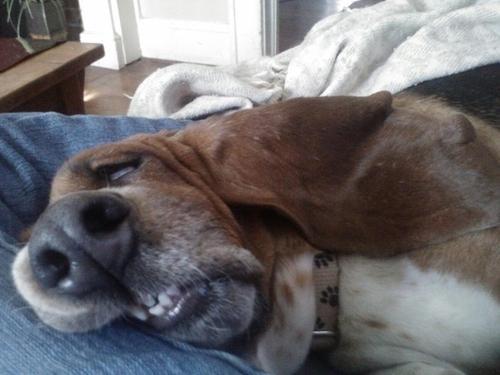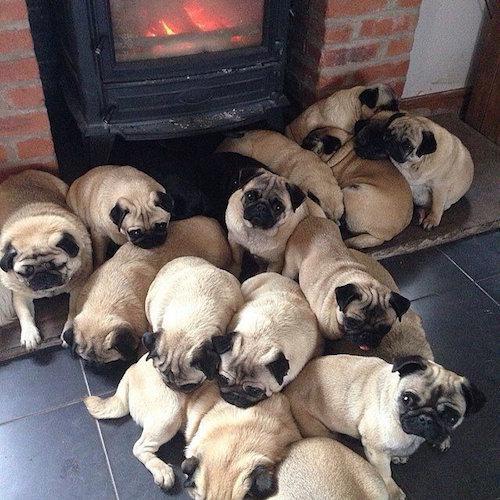The first image is the image on the left, the second image is the image on the right. Given the left and right images, does the statement "The right image contains no more than three dogs." hold true? Answer yes or no. No. The first image is the image on the left, the second image is the image on the right. Assess this claim about the two images: "At least one of the dogs is near a human.". Correct or not? Answer yes or no. No. 